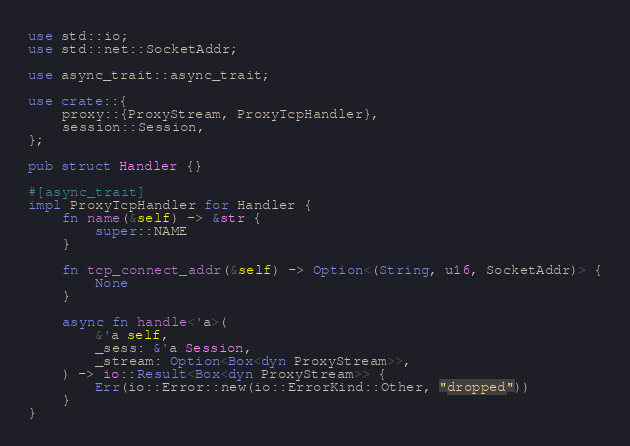Convert code to text. <code><loc_0><loc_0><loc_500><loc_500><_Rust_>use std::io;
use std::net::SocketAddr;

use async_trait::async_trait;

use crate::{
    proxy::{ProxyStream, ProxyTcpHandler},
    session::Session,
};

pub struct Handler {}

#[async_trait]
impl ProxyTcpHandler for Handler {
    fn name(&self) -> &str {
        super::NAME
    }

    fn tcp_connect_addr(&self) -> Option<(String, u16, SocketAddr)> {
        None
    }

    async fn handle<'a>(
        &'a self,
        _sess: &'a Session,
        _stream: Option<Box<dyn ProxyStream>>,
    ) -> io::Result<Box<dyn ProxyStream>> {
        Err(io::Error::new(io::ErrorKind::Other, "dropped"))
    }
}
</code> 